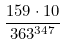<formula> <loc_0><loc_0><loc_500><loc_500>\frac { 1 5 9 \cdot 1 0 } { 3 6 3 ^ { 3 4 7 } }</formula> 